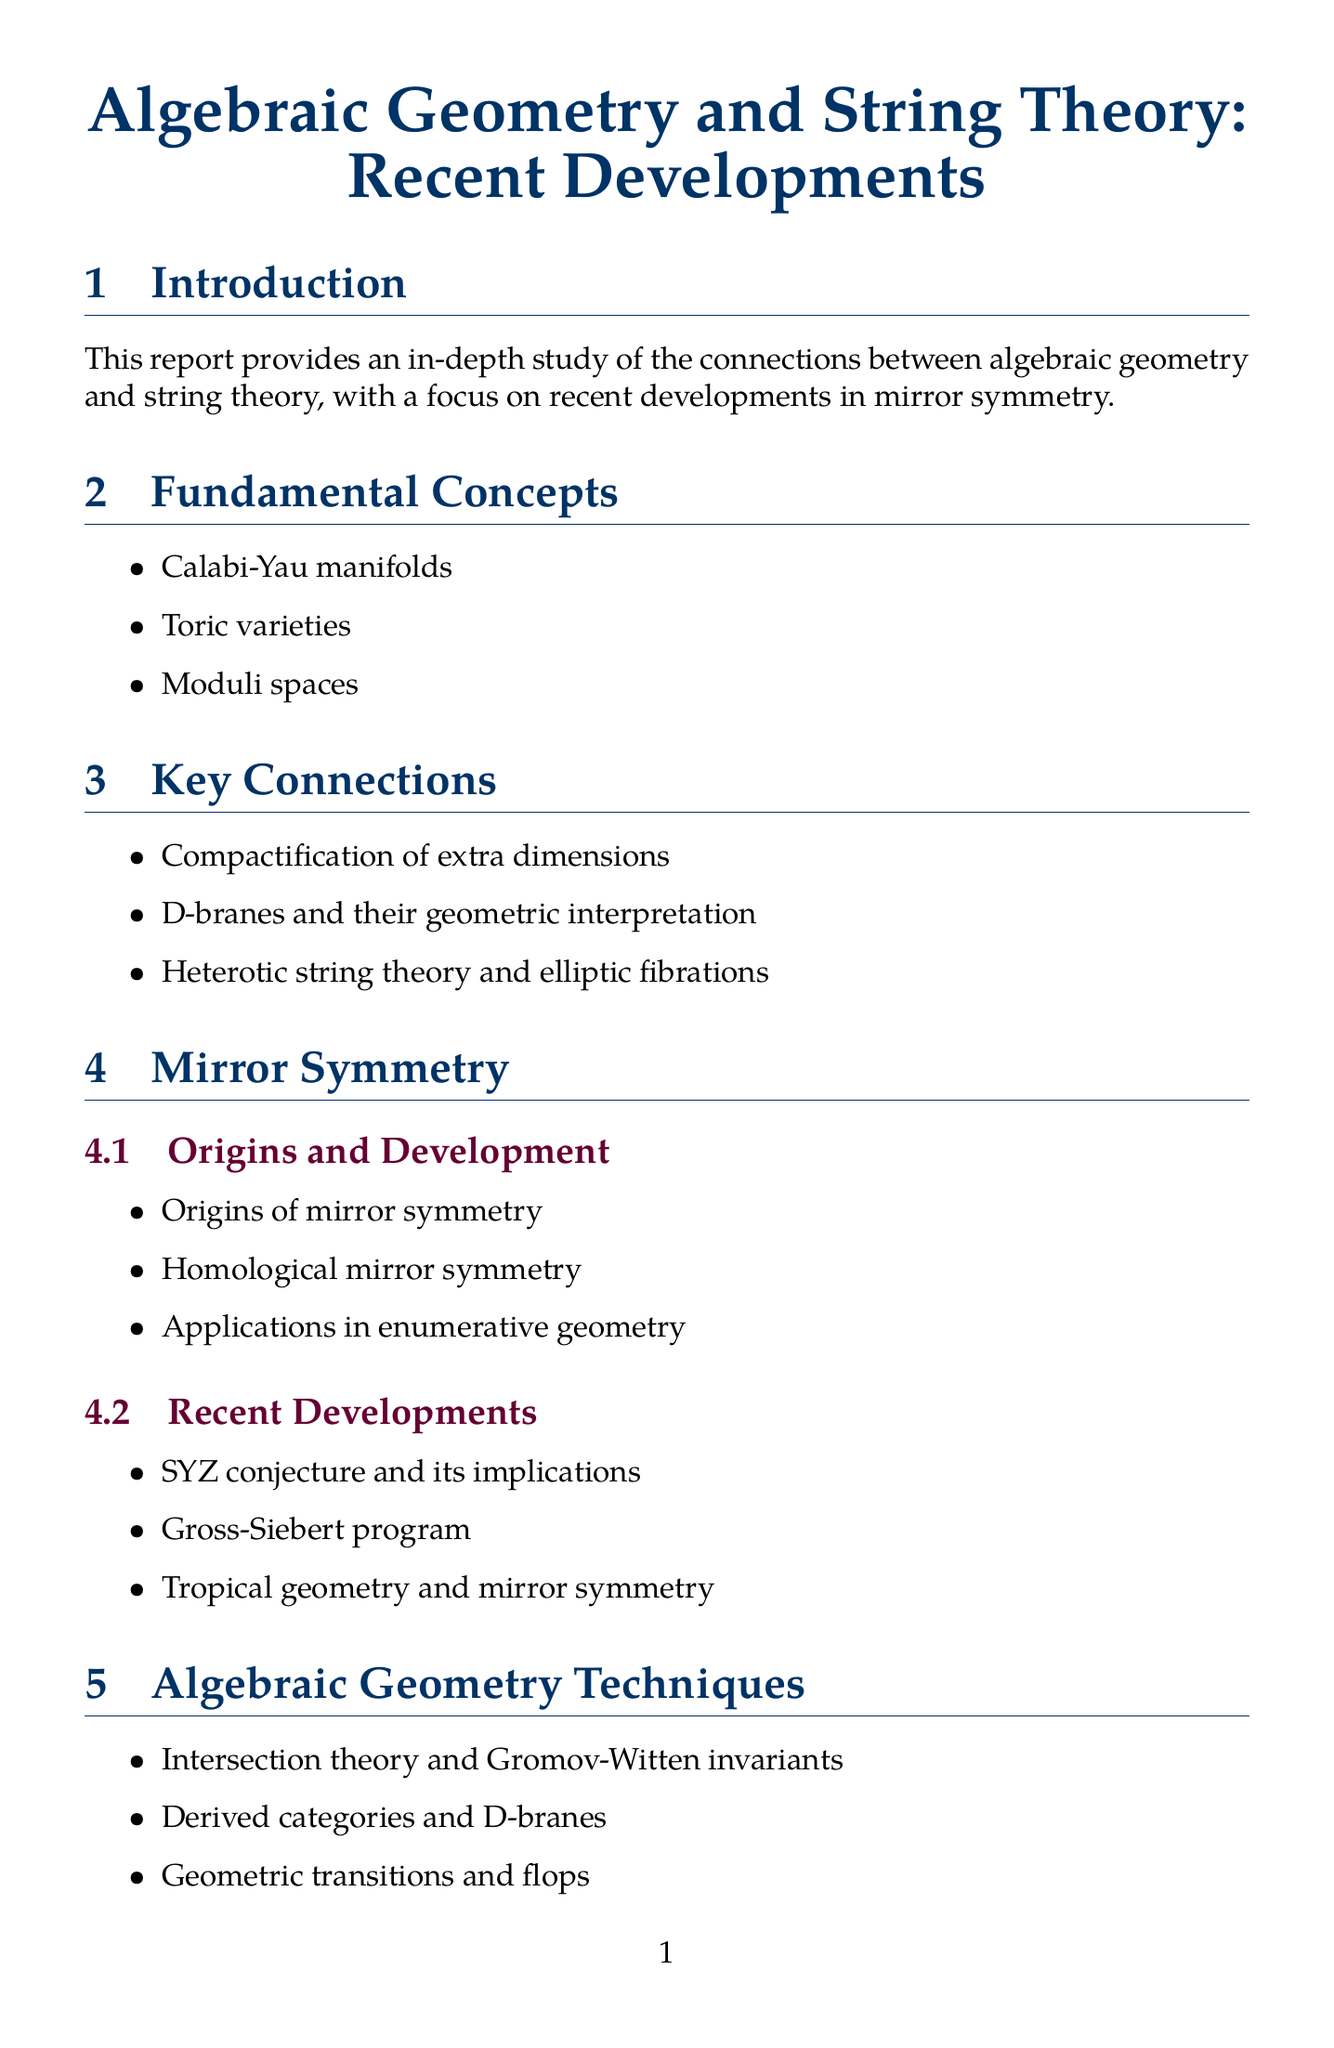What is the main focus of the report? The report focuses on the connections between algebraic geometry and string theory, specifically highlighting recent developments in mirror symmetry.
Answer: connections between algebraic geometry and string theory, recent developments in mirror symmetry Who formulated the homological mirror symmetry conjecture? Maxim Kontsevich is acknowledged in the document for formulating the homological mirror symmetry conjecture.
Answer: Maxim Kontsevich What are Calabi-Yau manifolds classified as in the report? Calabi-Yau manifolds are listed under fundamental concepts relevant to string theory.
Answer: fundamental concepts relevant to string theory When is the conference "Algebraic Geometry and Mathematical Physics" scheduled? The conference is scheduled for Fall 2024, as stated in the relevant conferences section.
Answer: Fall 2024 Which geometric interpretation is associated with D-branes? The document mentions "geometric interpretation" in relation to D-branes under key connections.
Answer: geometric interpretation What does the SYZ conjecture relate to in the context of mirror symmetry? The SYZ conjecture is connected to recent developments and its implications in mirror symmetry.
Answer: implications Name one recommended resource for studying mirror symmetry. The report lists "Mirror Symmetry" as a recommended resource authored by multiple researchers, including Kentaro Hori.
Answer: Mirror Symmetry What research tool is described as a computer algebra system? The document describes Macaulay2 as a computer algebra system for algebraic geometry calculations.
Answer: Macaulay2 